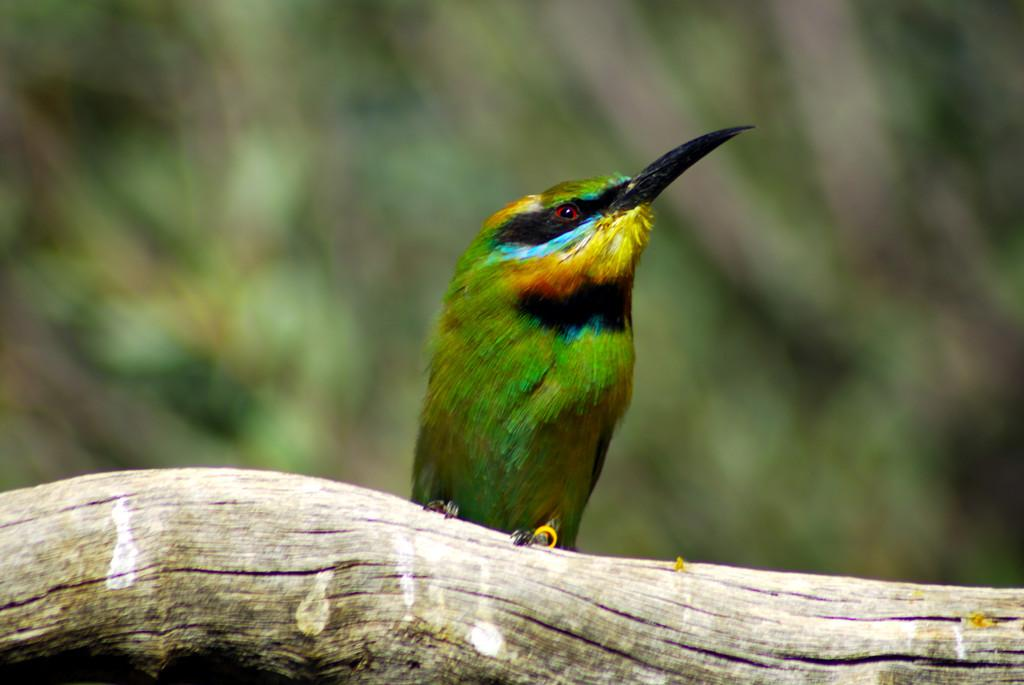What type of animal can be seen in the image? There is a bird in the image. Where is the bird located? The bird is sitting on a tree log. Can you describe the background of the image? The background of the image is blurred. What type of cloth is being used to start the mine in the image? There is no mine or cloth present in the image; it features a bird sitting on a tree log with a blurred background. 